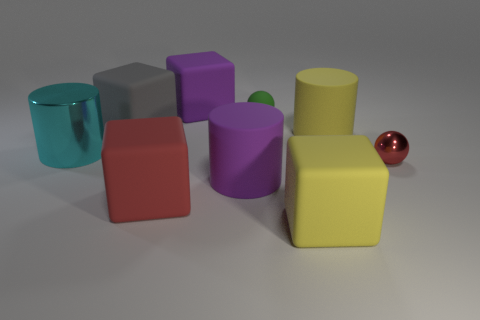How big is the purple matte object that is to the left of the big cylinder that is in front of the small metal sphere?
Your answer should be compact. Large. How many tiny things are cyan objects or blue balls?
Offer a terse response. 0. How many other objects are the same color as the tiny shiny thing?
Provide a succinct answer. 1. There is a red object that is behind the large red matte object; does it have the same size as the matte cylinder that is to the right of the yellow cube?
Your response must be concise. No. Are the green thing and the large block that is behind the large gray matte object made of the same material?
Your answer should be very brief. Yes. Are there more green matte objects that are to the left of the big gray matte cube than purple blocks that are behind the tiny green matte thing?
Offer a very short reply. No. What is the color of the metallic thing on the right side of the purple object in front of the tiny red ball?
Offer a very short reply. Red. What number of spheres are large brown matte objects or green rubber objects?
Your answer should be very brief. 1. What number of things are both on the right side of the big purple cylinder and in front of the shiny cylinder?
Give a very brief answer. 2. There is a sphere that is in front of the shiny cylinder; what is its color?
Your response must be concise. Red. 